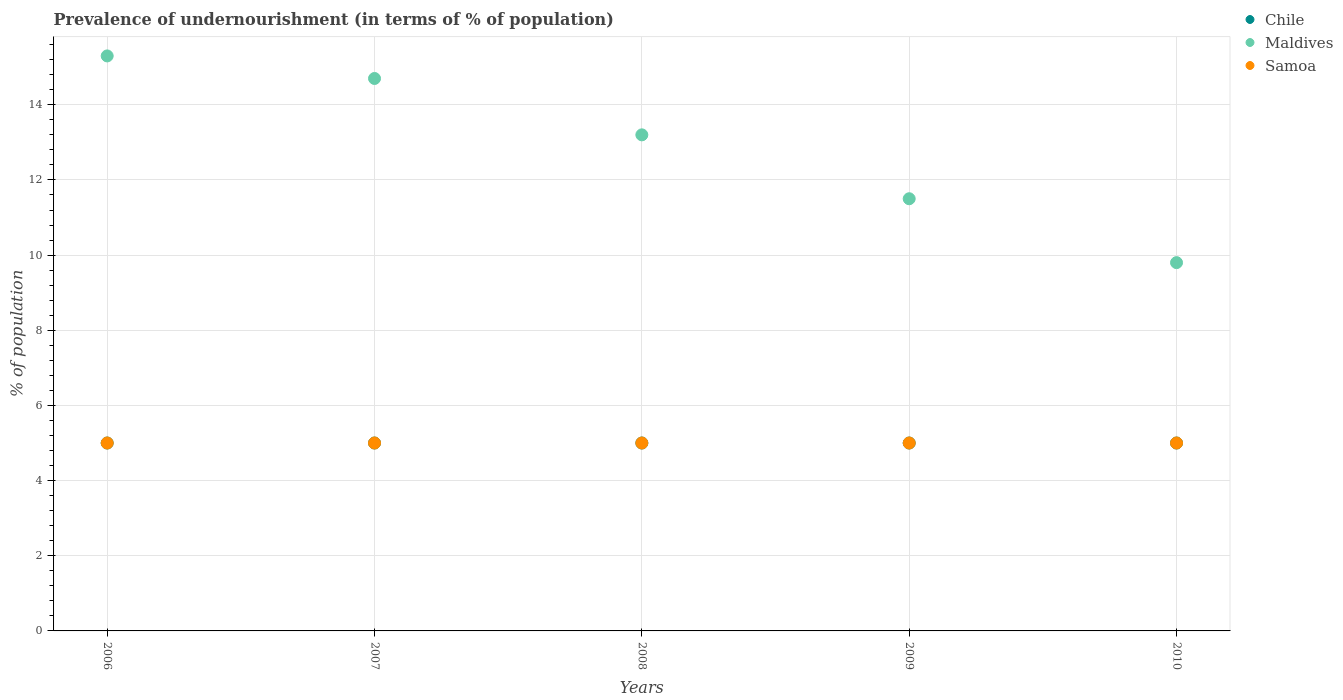How many different coloured dotlines are there?
Ensure brevity in your answer.  3. Is the number of dotlines equal to the number of legend labels?
Make the answer very short. Yes. Across all years, what is the minimum percentage of undernourished population in Chile?
Provide a succinct answer. 5. In which year was the percentage of undernourished population in Maldives minimum?
Your answer should be compact. 2010. What is the total percentage of undernourished population in Maldives in the graph?
Provide a short and direct response. 64.5. What is the difference between the percentage of undernourished population in Chile in 2009 and that in 2010?
Offer a very short reply. 0. What is the average percentage of undernourished population in Maldives per year?
Your answer should be very brief. 12.9. In the year 2010, what is the difference between the percentage of undernourished population in Maldives and percentage of undernourished population in Samoa?
Give a very brief answer. 4.8. What is the ratio of the percentage of undernourished population in Samoa in 2006 to that in 2007?
Ensure brevity in your answer.  1. Is the percentage of undernourished population in Maldives in 2006 less than that in 2008?
Provide a succinct answer. No. Is the difference between the percentage of undernourished population in Maldives in 2007 and 2008 greater than the difference between the percentage of undernourished population in Samoa in 2007 and 2008?
Your answer should be compact. Yes. What is the difference between the highest and the second highest percentage of undernourished population in Samoa?
Your answer should be compact. 0. Is the sum of the percentage of undernourished population in Maldives in 2007 and 2009 greater than the maximum percentage of undernourished population in Samoa across all years?
Ensure brevity in your answer.  Yes. Is it the case that in every year, the sum of the percentage of undernourished population in Chile and percentage of undernourished population in Maldives  is greater than the percentage of undernourished population in Samoa?
Provide a succinct answer. Yes. Does the percentage of undernourished population in Samoa monotonically increase over the years?
Provide a short and direct response. No. Is the percentage of undernourished population in Samoa strictly less than the percentage of undernourished population in Chile over the years?
Your answer should be very brief. No. How many dotlines are there?
Provide a succinct answer. 3. How many years are there in the graph?
Keep it short and to the point. 5. Does the graph contain any zero values?
Give a very brief answer. No. Does the graph contain grids?
Your answer should be compact. Yes. Where does the legend appear in the graph?
Make the answer very short. Top right. What is the title of the graph?
Offer a terse response. Prevalence of undernourishment (in terms of % of population). Does "Sub-Saharan Africa (all income levels)" appear as one of the legend labels in the graph?
Offer a very short reply. No. What is the label or title of the X-axis?
Provide a succinct answer. Years. What is the label or title of the Y-axis?
Ensure brevity in your answer.  % of population. What is the % of population of Chile in 2006?
Ensure brevity in your answer.  5. What is the % of population of Maldives in 2006?
Ensure brevity in your answer.  15.3. What is the % of population of Samoa in 2006?
Make the answer very short. 5. What is the % of population of Maldives in 2007?
Offer a terse response. 14.7. What is the % of population of Maldives in 2008?
Offer a very short reply. 13.2. What is the % of population in Samoa in 2008?
Your answer should be compact. 5. What is the % of population in Chile in 2009?
Offer a very short reply. 5. What is the % of population of Chile in 2010?
Make the answer very short. 5. What is the % of population of Maldives in 2010?
Your response must be concise. 9.8. What is the % of population in Samoa in 2010?
Ensure brevity in your answer.  5. Across all years, what is the maximum % of population in Chile?
Offer a very short reply. 5. Across all years, what is the minimum % of population of Chile?
Provide a succinct answer. 5. What is the total % of population in Maldives in the graph?
Ensure brevity in your answer.  64.5. What is the total % of population of Samoa in the graph?
Your answer should be very brief. 25. What is the difference between the % of population in Chile in 2006 and that in 2007?
Make the answer very short. 0. What is the difference between the % of population of Maldives in 2006 and that in 2007?
Your answer should be very brief. 0.6. What is the difference between the % of population of Chile in 2006 and that in 2009?
Ensure brevity in your answer.  0. What is the difference between the % of population of Maldives in 2006 and that in 2009?
Make the answer very short. 3.8. What is the difference between the % of population in Maldives in 2006 and that in 2010?
Make the answer very short. 5.5. What is the difference between the % of population of Samoa in 2006 and that in 2010?
Ensure brevity in your answer.  0. What is the difference between the % of population in Chile in 2007 and that in 2008?
Offer a very short reply. 0. What is the difference between the % of population of Chile in 2007 and that in 2009?
Provide a short and direct response. 0. What is the difference between the % of population of Samoa in 2007 and that in 2009?
Give a very brief answer. 0. What is the difference between the % of population of Chile in 2008 and that in 2009?
Your response must be concise. 0. What is the difference between the % of population of Samoa in 2008 and that in 2009?
Your answer should be compact. 0. What is the difference between the % of population in Samoa in 2009 and that in 2010?
Your answer should be compact. 0. What is the difference between the % of population in Chile in 2006 and the % of population in Samoa in 2007?
Your answer should be very brief. 0. What is the difference between the % of population of Maldives in 2006 and the % of population of Samoa in 2007?
Your answer should be compact. 10.3. What is the difference between the % of population in Chile in 2006 and the % of population in Maldives in 2008?
Keep it short and to the point. -8.2. What is the difference between the % of population of Chile in 2006 and the % of population of Maldives in 2009?
Ensure brevity in your answer.  -6.5. What is the difference between the % of population in Chile in 2006 and the % of population in Samoa in 2009?
Your response must be concise. 0. What is the difference between the % of population of Chile in 2006 and the % of population of Samoa in 2010?
Provide a succinct answer. 0. What is the difference between the % of population of Chile in 2007 and the % of population of Maldives in 2008?
Provide a succinct answer. -8.2. What is the difference between the % of population of Chile in 2007 and the % of population of Samoa in 2008?
Make the answer very short. 0. What is the difference between the % of population in Chile in 2007 and the % of population in Maldives in 2009?
Provide a succinct answer. -6.5. What is the difference between the % of population of Chile in 2007 and the % of population of Maldives in 2010?
Provide a short and direct response. -4.8. What is the difference between the % of population in Chile in 2007 and the % of population in Samoa in 2010?
Keep it short and to the point. 0. What is the difference between the % of population in Maldives in 2007 and the % of population in Samoa in 2010?
Make the answer very short. 9.7. What is the difference between the % of population of Maldives in 2008 and the % of population of Samoa in 2009?
Provide a short and direct response. 8.2. What is the difference between the % of population of Chile in 2009 and the % of population of Maldives in 2010?
Make the answer very short. -4.8. What is the difference between the % of population in Chile in 2009 and the % of population in Samoa in 2010?
Offer a terse response. 0. What is the average % of population of Chile per year?
Offer a terse response. 5. In the year 2006, what is the difference between the % of population in Maldives and % of population in Samoa?
Make the answer very short. 10.3. In the year 2007, what is the difference between the % of population in Chile and % of population in Samoa?
Offer a terse response. 0. In the year 2007, what is the difference between the % of population of Maldives and % of population of Samoa?
Offer a very short reply. 9.7. In the year 2008, what is the difference between the % of population in Chile and % of population in Maldives?
Give a very brief answer. -8.2. In the year 2008, what is the difference between the % of population of Maldives and % of population of Samoa?
Offer a very short reply. 8.2. In the year 2009, what is the difference between the % of population of Chile and % of population of Samoa?
Give a very brief answer. 0. In the year 2009, what is the difference between the % of population in Maldives and % of population in Samoa?
Offer a terse response. 6.5. In the year 2010, what is the difference between the % of population in Chile and % of population in Maldives?
Ensure brevity in your answer.  -4.8. In the year 2010, what is the difference between the % of population in Maldives and % of population in Samoa?
Provide a short and direct response. 4.8. What is the ratio of the % of population in Chile in 2006 to that in 2007?
Offer a terse response. 1. What is the ratio of the % of population of Maldives in 2006 to that in 2007?
Give a very brief answer. 1.04. What is the ratio of the % of population in Chile in 2006 to that in 2008?
Your response must be concise. 1. What is the ratio of the % of population of Maldives in 2006 to that in 2008?
Your answer should be very brief. 1.16. What is the ratio of the % of population of Chile in 2006 to that in 2009?
Give a very brief answer. 1. What is the ratio of the % of population in Maldives in 2006 to that in 2009?
Provide a short and direct response. 1.33. What is the ratio of the % of population in Maldives in 2006 to that in 2010?
Your answer should be compact. 1.56. What is the ratio of the % of population of Samoa in 2006 to that in 2010?
Ensure brevity in your answer.  1. What is the ratio of the % of population in Maldives in 2007 to that in 2008?
Your answer should be compact. 1.11. What is the ratio of the % of population in Chile in 2007 to that in 2009?
Ensure brevity in your answer.  1. What is the ratio of the % of population in Maldives in 2007 to that in 2009?
Provide a short and direct response. 1.28. What is the ratio of the % of population of Chile in 2008 to that in 2009?
Your response must be concise. 1. What is the ratio of the % of population in Maldives in 2008 to that in 2009?
Keep it short and to the point. 1.15. What is the ratio of the % of population in Samoa in 2008 to that in 2009?
Your response must be concise. 1. What is the ratio of the % of population of Maldives in 2008 to that in 2010?
Give a very brief answer. 1.35. What is the ratio of the % of population in Maldives in 2009 to that in 2010?
Make the answer very short. 1.17. What is the ratio of the % of population in Samoa in 2009 to that in 2010?
Your response must be concise. 1. What is the difference between the highest and the second highest % of population in Chile?
Your answer should be compact. 0. What is the difference between the highest and the second highest % of population of Maldives?
Offer a very short reply. 0.6. What is the difference between the highest and the second highest % of population in Samoa?
Your answer should be compact. 0. What is the difference between the highest and the lowest % of population in Maldives?
Your response must be concise. 5.5. What is the difference between the highest and the lowest % of population of Samoa?
Your answer should be compact. 0. 